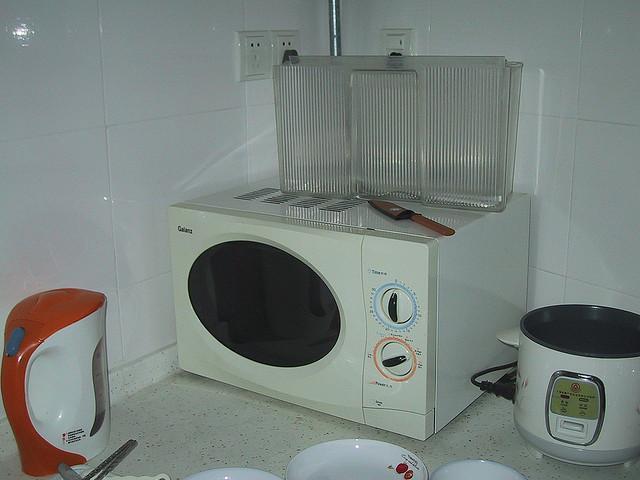How many red cars are there?
Give a very brief answer. 0. 